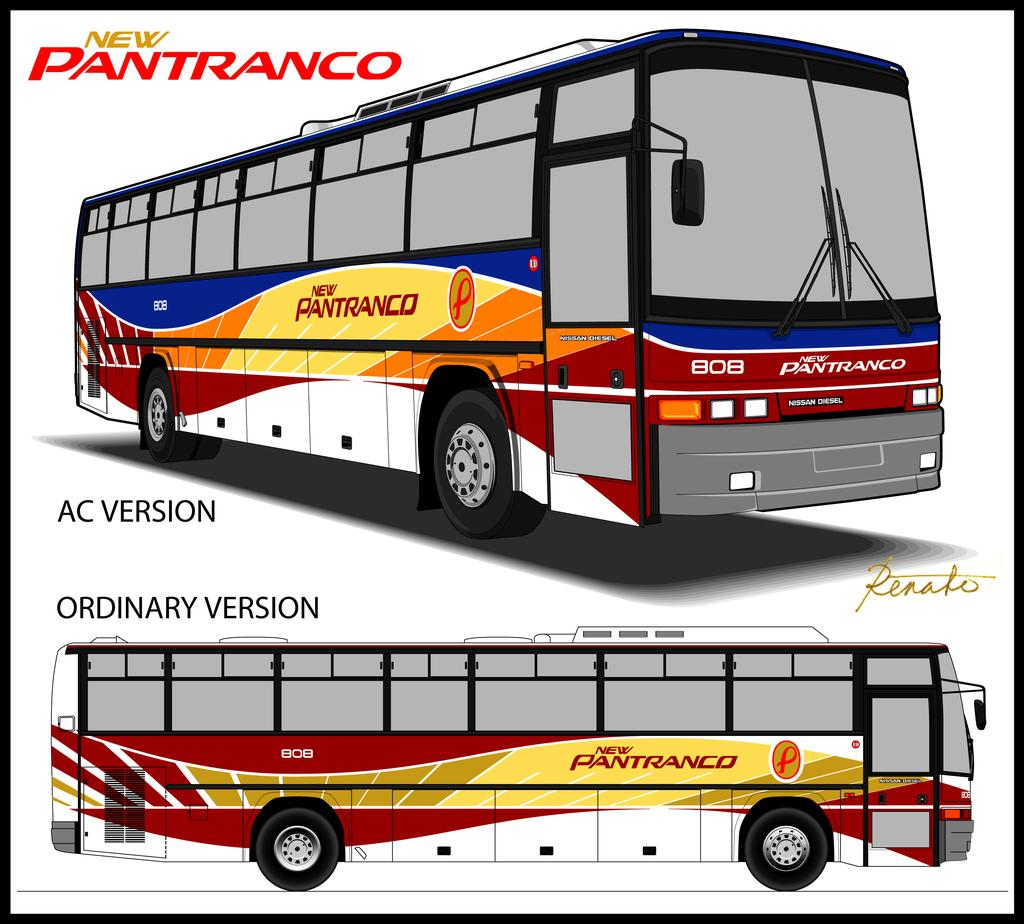What type of visual is the image? The image is a poster. What is shown on the poster? There are buses depicted on the poster. Are there any words or phrases on the poster? Yes, there is text present on the poster. What type of throat remedy is advertised on the poster? There is no throat remedy advertised on the poster; it features buses and text. How many potatoes are visible on the poster? There are no potatoes present on the poster. 